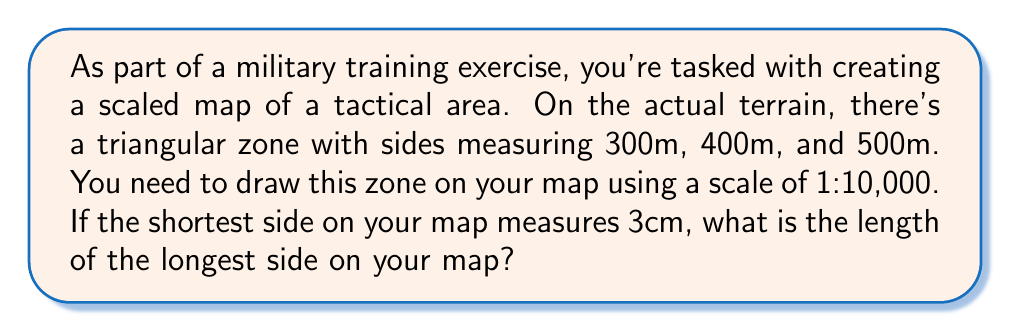Show me your answer to this math problem. Let's approach this step-by-step:

1) First, we need to understand the concept of similar triangles. The triangle on the map is similar to the actual triangle on the terrain, just scaled down.

2) We're given that the scale is 1:10,000. This means that 1 unit on the map represents 10,000 units in real life.

3) We're told that the shortest side on the map is 3cm. Let's find out what this corresponds to in real life:
   $3 \text{ cm} \times 10,000 = 30,000 \text{ cm} = 300 \text{ m}$

4) This confirms that the 3cm side on the map represents the 300m side in real life.

5) Now, we need to find the length of the 500m side on the map. We can set up a proportion:

   $$\frac{300 \text{ m}}{3 \text{ cm}} = \frac{500 \text{ m}}{x \text{ cm}}$$

6) Cross multiply:
   $300x = 3 \times 500$

7) Solve for x:
   $$x = \frac{3 \times 500}{300} = 5 \text{ cm}$$

Therefore, the longest side (500m in real life) will measure 5cm on the map.
Answer: 5 cm 